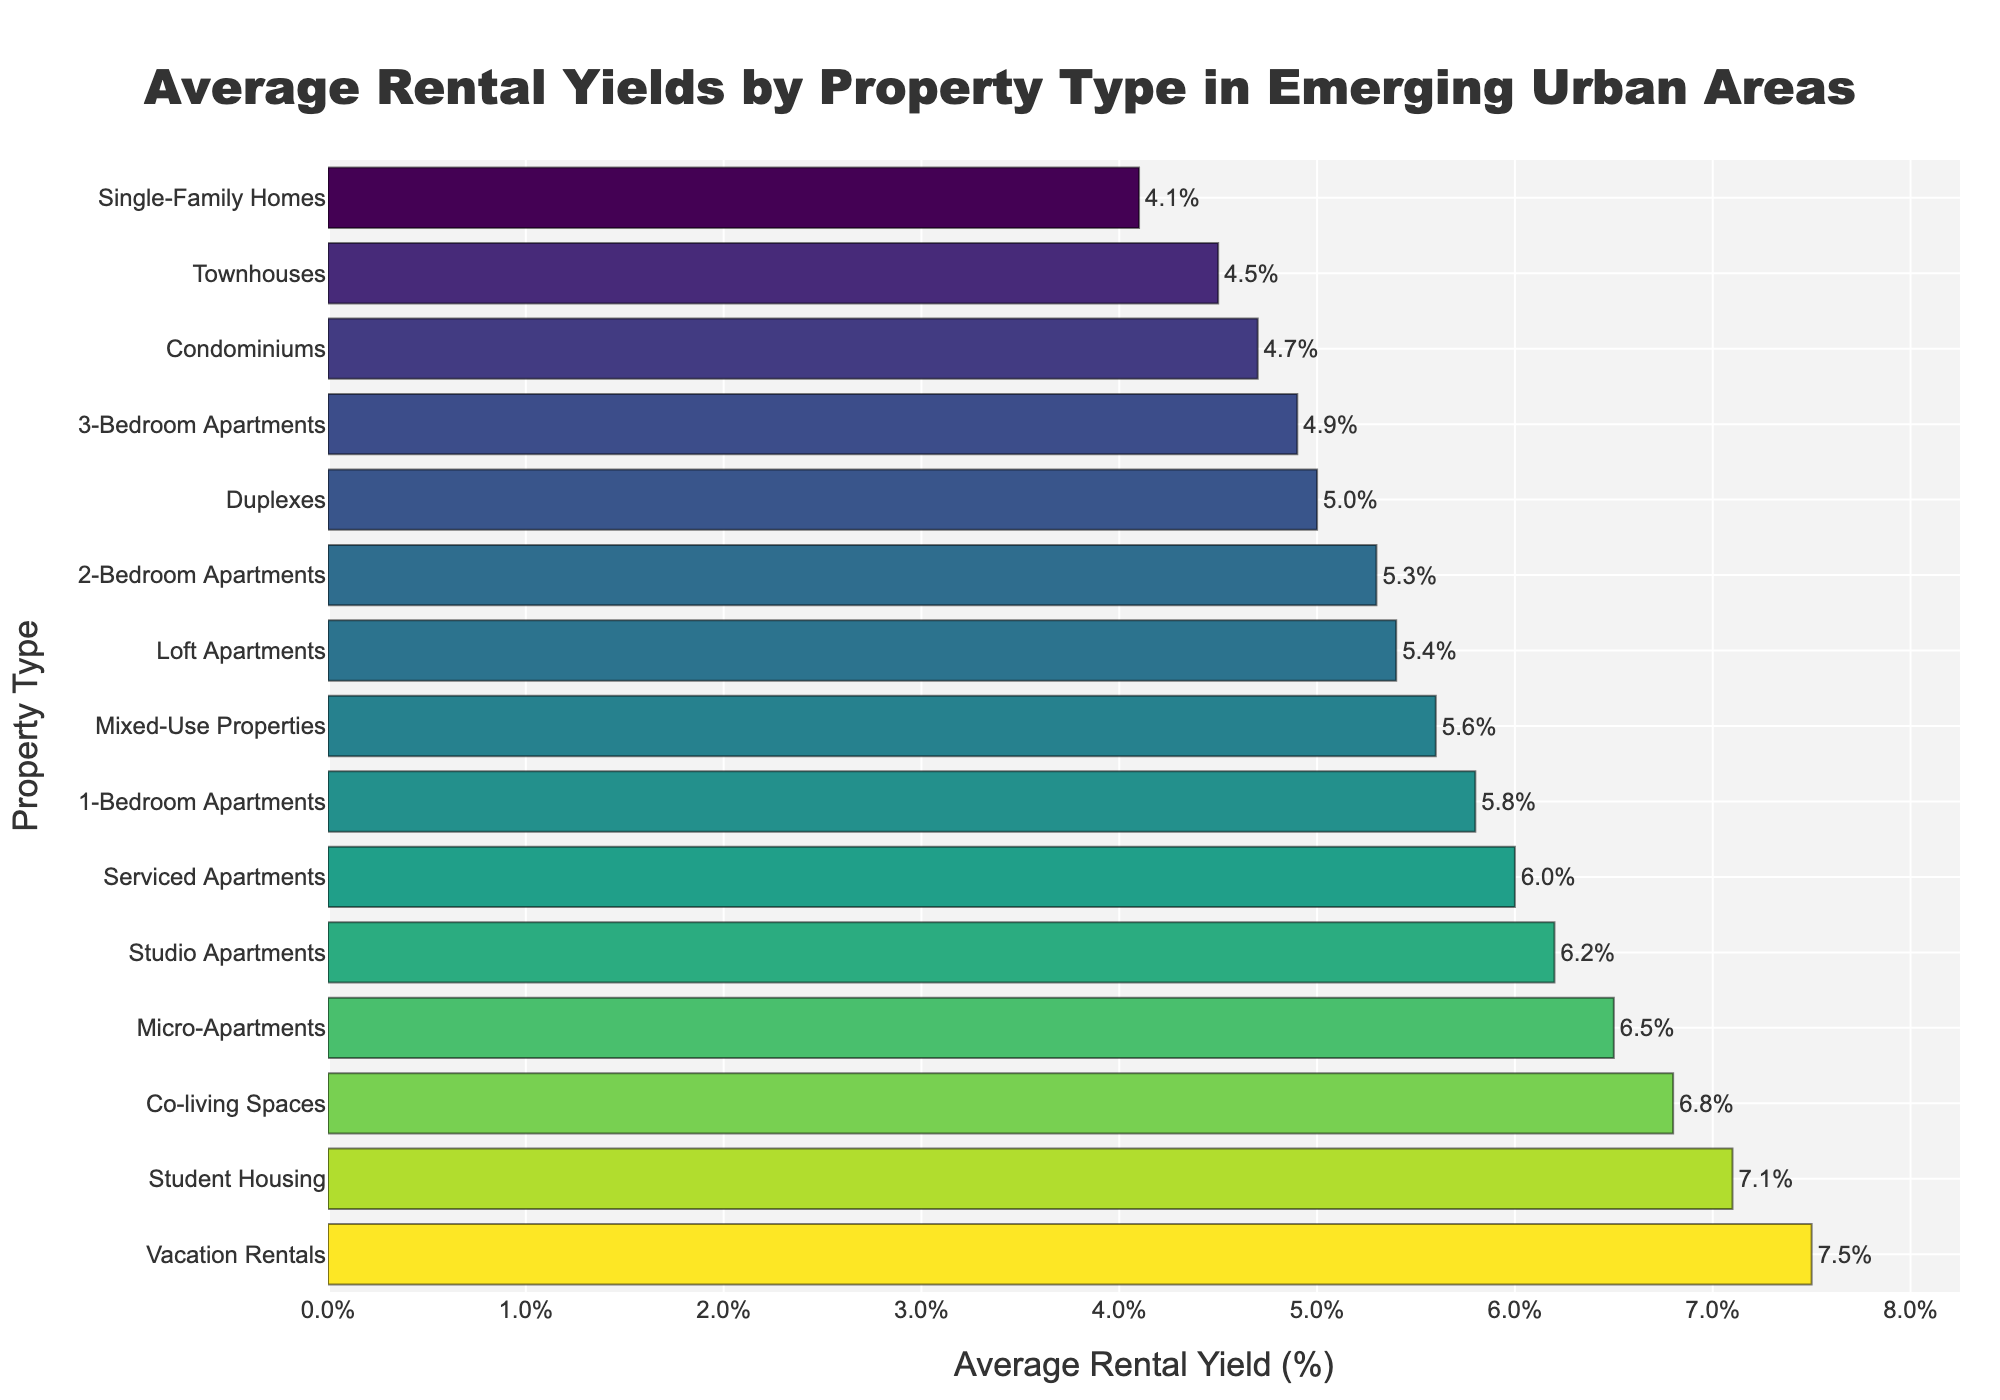What property type has the highest average rental yield? The tallest bar in the chart represents the property type with the highest average rental yield. Looking at the heights of the bars, Vacation Rentals have the highest yield.
Answer: Vacation Rentals What's the difference in average rental yield between the highest and lowest yielding property types? The highest yielding property type is "Vacation Rentals" with 7.5%, and the lowest is "Single-Family Homes" with 4.1%. The difference can be calculated as 7.5% - 4.1% = 3.4%.
Answer: 3.4% Which property type has a higher average rental yield: Studio Apartments or 2-Bedroom Apartments? By comparing the heights of the bars corresponding to "Studio Apartments" and "2-Bedroom Apartments", it is evident that "Studio Apartments" have an average rental yield of 6.2%, which is higher than the 5.3% yield for "2-Bedroom Apartments".
Answer: Studio Apartments What is the average rental yield for property types yielding more than 6%? The property types with yields more than 6% are "Micro-Apartments" (6.5%), "Co-living Spaces" (6.8%), "Vacation Rentals" (7.5%), "Student Housing" (7.1%), and "Studio Apartments" (6.2%). The average can be calculated by summing these yields and dividing by the number of property types: (6.5% + 6.8% + 7.5% + 7.1% + 6.2%) / 5 = 34.1% / 5 = 6.82%.
Answer: 6.82% Which property type falls in the middle in terms of average rental yield? To find the median, the property types need to be listed in ascending order and the middle value identified. There are 15 property types, so the median is the 8th value: "Loft Apartments" with a yield of 5.4%.
Answer: Loft Apartments What are the average rental yields for the property types with the second and third highest yields, and what is their combined yield? The second highest yield is "Co-living Spaces" (6.8%) and the third is "Micro-Apartments" (6.5%). Their combined yield is 6.8% + 6.5% = 13.3%.
Answer: 13.3% Which property type has a higher average rental yield: Serviced Apartments or Mixed-Use Properties? By comparing the heights of the bars for "Serviced Apartments" and "Mixed-Use Properties", it is evident that "Mixed-Use Properties" have an average rental yield of 5.6%, which is lower than the 6.0% yield for "Serviced Apartments".
Answer: Serviced Apartments What is the range of average rental yields in the figure? The range is calculated by subtracting the lowest average rental yield from the highest. The highest average rental yield is for "Vacation Rentals" at 7.5%, and the lowest is for "Single-Family Homes" at 4.1%. So, the range is 7.5% - 4.1% = 3.4%.
Answer: 3.4% How does the average rental yield of "Townhouses" compare to that of "Duplexes"? The bar corresponding to "Townhouses" shows a yield of 4.5%, whereas "Duplexes" show a yield of 5.0%. Thus, "Duplexes" have a higher average rental yield than "Townhouses".
Answer: Duplexes 